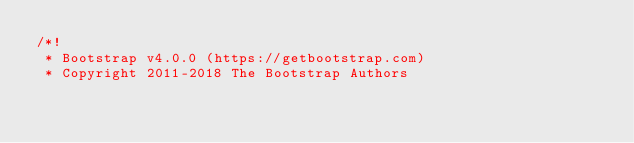<code> <loc_0><loc_0><loc_500><loc_500><_CSS_>/*!
 * Bootstrap v4.0.0 (https://getbootstrap.com)
 * Copyright 2011-2018 The Bootstrap Authors</code> 